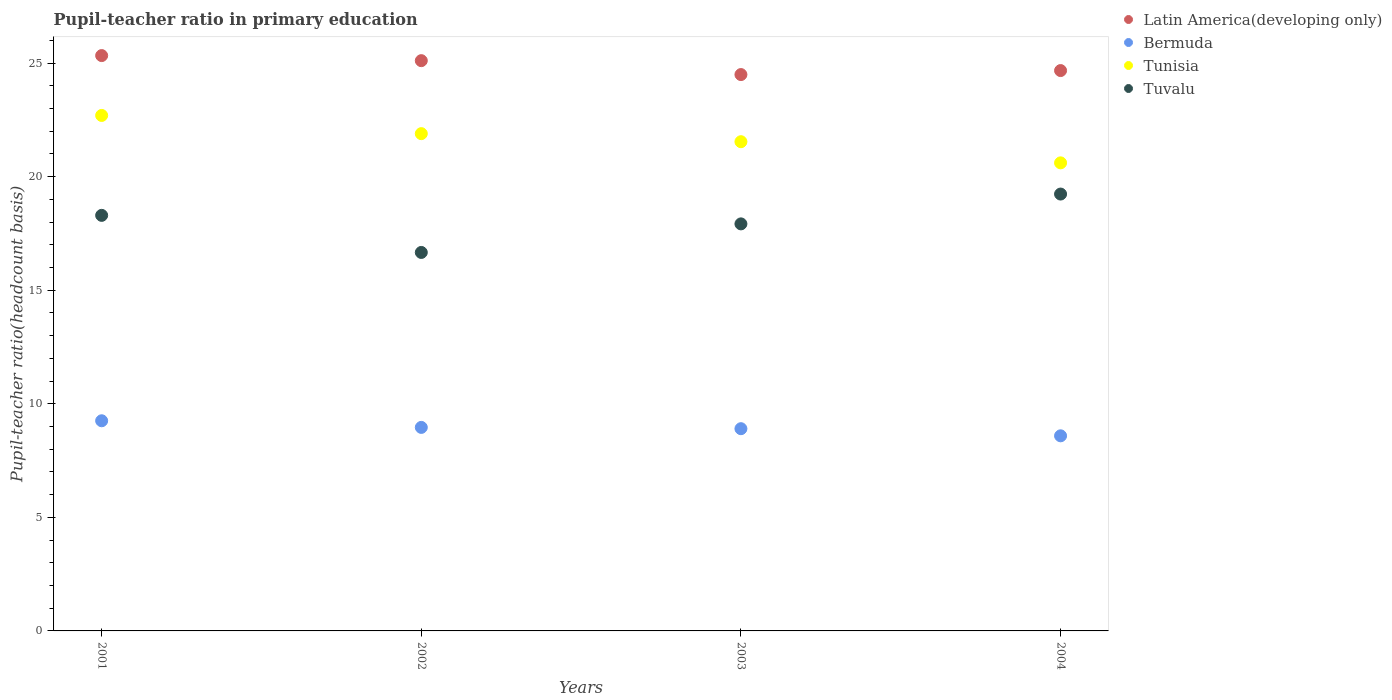How many different coloured dotlines are there?
Give a very brief answer. 4. What is the pupil-teacher ratio in primary education in Bermuda in 2001?
Give a very brief answer. 9.25. Across all years, what is the maximum pupil-teacher ratio in primary education in Tuvalu?
Provide a short and direct response. 19.23. Across all years, what is the minimum pupil-teacher ratio in primary education in Tunisia?
Your answer should be very brief. 20.61. What is the total pupil-teacher ratio in primary education in Tuvalu in the graph?
Your answer should be very brief. 72.11. What is the difference between the pupil-teacher ratio in primary education in Tunisia in 2002 and that in 2004?
Provide a succinct answer. 1.29. What is the difference between the pupil-teacher ratio in primary education in Tunisia in 2002 and the pupil-teacher ratio in primary education in Bermuda in 2001?
Give a very brief answer. 12.64. What is the average pupil-teacher ratio in primary education in Latin America(developing only) per year?
Your answer should be compact. 24.9. In the year 2001, what is the difference between the pupil-teacher ratio in primary education in Bermuda and pupil-teacher ratio in primary education in Tuvalu?
Make the answer very short. -9.04. In how many years, is the pupil-teacher ratio in primary education in Bermuda greater than 15?
Your answer should be very brief. 0. What is the ratio of the pupil-teacher ratio in primary education in Tunisia in 2001 to that in 2003?
Provide a short and direct response. 1.05. Is the pupil-teacher ratio in primary education in Tuvalu in 2002 less than that in 2004?
Provide a succinct answer. Yes. What is the difference between the highest and the second highest pupil-teacher ratio in primary education in Tunisia?
Offer a very short reply. 0.8. What is the difference between the highest and the lowest pupil-teacher ratio in primary education in Tunisia?
Your answer should be very brief. 2.09. Is it the case that in every year, the sum of the pupil-teacher ratio in primary education in Latin America(developing only) and pupil-teacher ratio in primary education in Bermuda  is greater than the sum of pupil-teacher ratio in primary education in Tuvalu and pupil-teacher ratio in primary education in Tunisia?
Give a very brief answer. No. Is the pupil-teacher ratio in primary education in Tunisia strictly greater than the pupil-teacher ratio in primary education in Latin America(developing only) over the years?
Provide a succinct answer. No. What is the difference between two consecutive major ticks on the Y-axis?
Your answer should be compact. 5. Does the graph contain grids?
Your response must be concise. No. Where does the legend appear in the graph?
Provide a short and direct response. Top right. How many legend labels are there?
Offer a terse response. 4. What is the title of the graph?
Provide a succinct answer. Pupil-teacher ratio in primary education. Does "Sudan" appear as one of the legend labels in the graph?
Provide a short and direct response. No. What is the label or title of the X-axis?
Make the answer very short. Years. What is the label or title of the Y-axis?
Offer a terse response. Pupil-teacher ratio(headcount basis). What is the Pupil-teacher ratio(headcount basis) in Latin America(developing only) in 2001?
Give a very brief answer. 25.33. What is the Pupil-teacher ratio(headcount basis) in Bermuda in 2001?
Keep it short and to the point. 9.25. What is the Pupil-teacher ratio(headcount basis) of Tunisia in 2001?
Give a very brief answer. 22.69. What is the Pupil-teacher ratio(headcount basis) of Tuvalu in 2001?
Your answer should be very brief. 18.29. What is the Pupil-teacher ratio(headcount basis) in Latin America(developing only) in 2002?
Give a very brief answer. 25.11. What is the Pupil-teacher ratio(headcount basis) in Bermuda in 2002?
Your response must be concise. 8.96. What is the Pupil-teacher ratio(headcount basis) in Tunisia in 2002?
Provide a succinct answer. 21.89. What is the Pupil-teacher ratio(headcount basis) in Tuvalu in 2002?
Your answer should be compact. 16.66. What is the Pupil-teacher ratio(headcount basis) of Latin America(developing only) in 2003?
Your answer should be very brief. 24.49. What is the Pupil-teacher ratio(headcount basis) of Bermuda in 2003?
Make the answer very short. 8.9. What is the Pupil-teacher ratio(headcount basis) in Tunisia in 2003?
Offer a terse response. 21.54. What is the Pupil-teacher ratio(headcount basis) of Tuvalu in 2003?
Keep it short and to the point. 17.92. What is the Pupil-teacher ratio(headcount basis) in Latin America(developing only) in 2004?
Offer a terse response. 24.67. What is the Pupil-teacher ratio(headcount basis) in Bermuda in 2004?
Keep it short and to the point. 8.59. What is the Pupil-teacher ratio(headcount basis) of Tunisia in 2004?
Your answer should be compact. 20.61. What is the Pupil-teacher ratio(headcount basis) of Tuvalu in 2004?
Your response must be concise. 19.23. Across all years, what is the maximum Pupil-teacher ratio(headcount basis) in Latin America(developing only)?
Provide a succinct answer. 25.33. Across all years, what is the maximum Pupil-teacher ratio(headcount basis) in Bermuda?
Your answer should be very brief. 9.25. Across all years, what is the maximum Pupil-teacher ratio(headcount basis) in Tunisia?
Your answer should be compact. 22.69. Across all years, what is the maximum Pupil-teacher ratio(headcount basis) of Tuvalu?
Your response must be concise. 19.23. Across all years, what is the minimum Pupil-teacher ratio(headcount basis) of Latin America(developing only)?
Provide a succinct answer. 24.49. Across all years, what is the minimum Pupil-teacher ratio(headcount basis) of Bermuda?
Offer a very short reply. 8.59. Across all years, what is the minimum Pupil-teacher ratio(headcount basis) of Tunisia?
Provide a succinct answer. 20.61. Across all years, what is the minimum Pupil-teacher ratio(headcount basis) in Tuvalu?
Provide a succinct answer. 16.66. What is the total Pupil-teacher ratio(headcount basis) of Latin America(developing only) in the graph?
Your answer should be compact. 99.6. What is the total Pupil-teacher ratio(headcount basis) in Bermuda in the graph?
Keep it short and to the point. 35.7. What is the total Pupil-teacher ratio(headcount basis) of Tunisia in the graph?
Your response must be concise. 86.73. What is the total Pupil-teacher ratio(headcount basis) of Tuvalu in the graph?
Your answer should be compact. 72.11. What is the difference between the Pupil-teacher ratio(headcount basis) of Latin America(developing only) in 2001 and that in 2002?
Offer a very short reply. 0.22. What is the difference between the Pupil-teacher ratio(headcount basis) of Bermuda in 2001 and that in 2002?
Offer a very short reply. 0.29. What is the difference between the Pupil-teacher ratio(headcount basis) in Tunisia in 2001 and that in 2002?
Provide a short and direct response. 0.8. What is the difference between the Pupil-teacher ratio(headcount basis) in Tuvalu in 2001 and that in 2002?
Your answer should be very brief. 1.63. What is the difference between the Pupil-teacher ratio(headcount basis) of Latin America(developing only) in 2001 and that in 2003?
Provide a succinct answer. 0.84. What is the difference between the Pupil-teacher ratio(headcount basis) of Bermuda in 2001 and that in 2003?
Your answer should be very brief. 0.35. What is the difference between the Pupil-teacher ratio(headcount basis) of Tunisia in 2001 and that in 2003?
Offer a very short reply. 1.16. What is the difference between the Pupil-teacher ratio(headcount basis) of Tuvalu in 2001 and that in 2003?
Your answer should be compact. 0.37. What is the difference between the Pupil-teacher ratio(headcount basis) of Latin America(developing only) in 2001 and that in 2004?
Give a very brief answer. 0.66. What is the difference between the Pupil-teacher ratio(headcount basis) of Bermuda in 2001 and that in 2004?
Offer a very short reply. 0.66. What is the difference between the Pupil-teacher ratio(headcount basis) in Tunisia in 2001 and that in 2004?
Provide a succinct answer. 2.09. What is the difference between the Pupil-teacher ratio(headcount basis) of Tuvalu in 2001 and that in 2004?
Offer a terse response. -0.94. What is the difference between the Pupil-teacher ratio(headcount basis) in Latin America(developing only) in 2002 and that in 2003?
Make the answer very short. 0.61. What is the difference between the Pupil-teacher ratio(headcount basis) of Bermuda in 2002 and that in 2003?
Make the answer very short. 0.06. What is the difference between the Pupil-teacher ratio(headcount basis) of Tunisia in 2002 and that in 2003?
Offer a terse response. 0.35. What is the difference between the Pupil-teacher ratio(headcount basis) in Tuvalu in 2002 and that in 2003?
Your answer should be very brief. -1.26. What is the difference between the Pupil-teacher ratio(headcount basis) in Latin America(developing only) in 2002 and that in 2004?
Provide a succinct answer. 0.44. What is the difference between the Pupil-teacher ratio(headcount basis) in Bermuda in 2002 and that in 2004?
Ensure brevity in your answer.  0.37. What is the difference between the Pupil-teacher ratio(headcount basis) of Tunisia in 2002 and that in 2004?
Make the answer very short. 1.29. What is the difference between the Pupil-teacher ratio(headcount basis) in Tuvalu in 2002 and that in 2004?
Your answer should be compact. -2.57. What is the difference between the Pupil-teacher ratio(headcount basis) in Latin America(developing only) in 2003 and that in 2004?
Provide a succinct answer. -0.18. What is the difference between the Pupil-teacher ratio(headcount basis) of Bermuda in 2003 and that in 2004?
Give a very brief answer. 0.31. What is the difference between the Pupil-teacher ratio(headcount basis) of Tunisia in 2003 and that in 2004?
Your response must be concise. 0.93. What is the difference between the Pupil-teacher ratio(headcount basis) of Tuvalu in 2003 and that in 2004?
Your answer should be very brief. -1.31. What is the difference between the Pupil-teacher ratio(headcount basis) of Latin America(developing only) in 2001 and the Pupil-teacher ratio(headcount basis) of Bermuda in 2002?
Provide a succinct answer. 16.37. What is the difference between the Pupil-teacher ratio(headcount basis) in Latin America(developing only) in 2001 and the Pupil-teacher ratio(headcount basis) in Tunisia in 2002?
Your response must be concise. 3.44. What is the difference between the Pupil-teacher ratio(headcount basis) of Latin America(developing only) in 2001 and the Pupil-teacher ratio(headcount basis) of Tuvalu in 2002?
Offer a very short reply. 8.67. What is the difference between the Pupil-teacher ratio(headcount basis) of Bermuda in 2001 and the Pupil-teacher ratio(headcount basis) of Tunisia in 2002?
Your response must be concise. -12.64. What is the difference between the Pupil-teacher ratio(headcount basis) in Bermuda in 2001 and the Pupil-teacher ratio(headcount basis) in Tuvalu in 2002?
Offer a very short reply. -7.41. What is the difference between the Pupil-teacher ratio(headcount basis) in Tunisia in 2001 and the Pupil-teacher ratio(headcount basis) in Tuvalu in 2002?
Your answer should be very brief. 6.03. What is the difference between the Pupil-teacher ratio(headcount basis) in Latin America(developing only) in 2001 and the Pupil-teacher ratio(headcount basis) in Bermuda in 2003?
Give a very brief answer. 16.43. What is the difference between the Pupil-teacher ratio(headcount basis) in Latin America(developing only) in 2001 and the Pupil-teacher ratio(headcount basis) in Tunisia in 2003?
Give a very brief answer. 3.79. What is the difference between the Pupil-teacher ratio(headcount basis) in Latin America(developing only) in 2001 and the Pupil-teacher ratio(headcount basis) in Tuvalu in 2003?
Offer a very short reply. 7.41. What is the difference between the Pupil-teacher ratio(headcount basis) of Bermuda in 2001 and the Pupil-teacher ratio(headcount basis) of Tunisia in 2003?
Keep it short and to the point. -12.29. What is the difference between the Pupil-teacher ratio(headcount basis) of Bermuda in 2001 and the Pupil-teacher ratio(headcount basis) of Tuvalu in 2003?
Make the answer very short. -8.67. What is the difference between the Pupil-teacher ratio(headcount basis) in Tunisia in 2001 and the Pupil-teacher ratio(headcount basis) in Tuvalu in 2003?
Provide a succinct answer. 4.77. What is the difference between the Pupil-teacher ratio(headcount basis) in Latin America(developing only) in 2001 and the Pupil-teacher ratio(headcount basis) in Bermuda in 2004?
Ensure brevity in your answer.  16.74. What is the difference between the Pupil-teacher ratio(headcount basis) in Latin America(developing only) in 2001 and the Pupil-teacher ratio(headcount basis) in Tunisia in 2004?
Make the answer very short. 4.72. What is the difference between the Pupil-teacher ratio(headcount basis) in Latin America(developing only) in 2001 and the Pupil-teacher ratio(headcount basis) in Tuvalu in 2004?
Your answer should be compact. 6.1. What is the difference between the Pupil-teacher ratio(headcount basis) of Bermuda in 2001 and the Pupil-teacher ratio(headcount basis) of Tunisia in 2004?
Your answer should be compact. -11.35. What is the difference between the Pupil-teacher ratio(headcount basis) in Bermuda in 2001 and the Pupil-teacher ratio(headcount basis) in Tuvalu in 2004?
Provide a succinct answer. -9.98. What is the difference between the Pupil-teacher ratio(headcount basis) of Tunisia in 2001 and the Pupil-teacher ratio(headcount basis) of Tuvalu in 2004?
Keep it short and to the point. 3.46. What is the difference between the Pupil-teacher ratio(headcount basis) in Latin America(developing only) in 2002 and the Pupil-teacher ratio(headcount basis) in Bermuda in 2003?
Offer a terse response. 16.2. What is the difference between the Pupil-teacher ratio(headcount basis) in Latin America(developing only) in 2002 and the Pupil-teacher ratio(headcount basis) in Tunisia in 2003?
Ensure brevity in your answer.  3.57. What is the difference between the Pupil-teacher ratio(headcount basis) of Latin America(developing only) in 2002 and the Pupil-teacher ratio(headcount basis) of Tuvalu in 2003?
Give a very brief answer. 7.19. What is the difference between the Pupil-teacher ratio(headcount basis) in Bermuda in 2002 and the Pupil-teacher ratio(headcount basis) in Tunisia in 2003?
Keep it short and to the point. -12.58. What is the difference between the Pupil-teacher ratio(headcount basis) of Bermuda in 2002 and the Pupil-teacher ratio(headcount basis) of Tuvalu in 2003?
Make the answer very short. -8.96. What is the difference between the Pupil-teacher ratio(headcount basis) in Tunisia in 2002 and the Pupil-teacher ratio(headcount basis) in Tuvalu in 2003?
Give a very brief answer. 3.97. What is the difference between the Pupil-teacher ratio(headcount basis) in Latin America(developing only) in 2002 and the Pupil-teacher ratio(headcount basis) in Bermuda in 2004?
Offer a terse response. 16.52. What is the difference between the Pupil-teacher ratio(headcount basis) of Latin America(developing only) in 2002 and the Pupil-teacher ratio(headcount basis) of Tunisia in 2004?
Your response must be concise. 4.5. What is the difference between the Pupil-teacher ratio(headcount basis) in Latin America(developing only) in 2002 and the Pupil-teacher ratio(headcount basis) in Tuvalu in 2004?
Your answer should be very brief. 5.87. What is the difference between the Pupil-teacher ratio(headcount basis) in Bermuda in 2002 and the Pupil-teacher ratio(headcount basis) in Tunisia in 2004?
Ensure brevity in your answer.  -11.65. What is the difference between the Pupil-teacher ratio(headcount basis) in Bermuda in 2002 and the Pupil-teacher ratio(headcount basis) in Tuvalu in 2004?
Provide a succinct answer. -10.27. What is the difference between the Pupil-teacher ratio(headcount basis) in Tunisia in 2002 and the Pupil-teacher ratio(headcount basis) in Tuvalu in 2004?
Your response must be concise. 2.66. What is the difference between the Pupil-teacher ratio(headcount basis) in Latin America(developing only) in 2003 and the Pupil-teacher ratio(headcount basis) in Bermuda in 2004?
Provide a short and direct response. 15.9. What is the difference between the Pupil-teacher ratio(headcount basis) of Latin America(developing only) in 2003 and the Pupil-teacher ratio(headcount basis) of Tunisia in 2004?
Your response must be concise. 3.89. What is the difference between the Pupil-teacher ratio(headcount basis) of Latin America(developing only) in 2003 and the Pupil-teacher ratio(headcount basis) of Tuvalu in 2004?
Your answer should be very brief. 5.26. What is the difference between the Pupil-teacher ratio(headcount basis) of Bermuda in 2003 and the Pupil-teacher ratio(headcount basis) of Tunisia in 2004?
Your answer should be very brief. -11.7. What is the difference between the Pupil-teacher ratio(headcount basis) in Bermuda in 2003 and the Pupil-teacher ratio(headcount basis) in Tuvalu in 2004?
Provide a short and direct response. -10.33. What is the difference between the Pupil-teacher ratio(headcount basis) in Tunisia in 2003 and the Pupil-teacher ratio(headcount basis) in Tuvalu in 2004?
Give a very brief answer. 2.3. What is the average Pupil-teacher ratio(headcount basis) of Latin America(developing only) per year?
Provide a short and direct response. 24.9. What is the average Pupil-teacher ratio(headcount basis) in Bermuda per year?
Your answer should be compact. 8.93. What is the average Pupil-teacher ratio(headcount basis) of Tunisia per year?
Offer a terse response. 21.68. What is the average Pupil-teacher ratio(headcount basis) of Tuvalu per year?
Your response must be concise. 18.03. In the year 2001, what is the difference between the Pupil-teacher ratio(headcount basis) of Latin America(developing only) and Pupil-teacher ratio(headcount basis) of Bermuda?
Give a very brief answer. 16.08. In the year 2001, what is the difference between the Pupil-teacher ratio(headcount basis) in Latin America(developing only) and Pupil-teacher ratio(headcount basis) in Tunisia?
Offer a very short reply. 2.64. In the year 2001, what is the difference between the Pupil-teacher ratio(headcount basis) in Latin America(developing only) and Pupil-teacher ratio(headcount basis) in Tuvalu?
Your answer should be compact. 7.03. In the year 2001, what is the difference between the Pupil-teacher ratio(headcount basis) in Bermuda and Pupil-teacher ratio(headcount basis) in Tunisia?
Your answer should be very brief. -13.44. In the year 2001, what is the difference between the Pupil-teacher ratio(headcount basis) of Bermuda and Pupil-teacher ratio(headcount basis) of Tuvalu?
Ensure brevity in your answer.  -9.04. In the year 2001, what is the difference between the Pupil-teacher ratio(headcount basis) in Tunisia and Pupil-teacher ratio(headcount basis) in Tuvalu?
Your response must be concise. 4.4. In the year 2002, what is the difference between the Pupil-teacher ratio(headcount basis) of Latin America(developing only) and Pupil-teacher ratio(headcount basis) of Bermuda?
Offer a very short reply. 16.15. In the year 2002, what is the difference between the Pupil-teacher ratio(headcount basis) in Latin America(developing only) and Pupil-teacher ratio(headcount basis) in Tunisia?
Make the answer very short. 3.21. In the year 2002, what is the difference between the Pupil-teacher ratio(headcount basis) in Latin America(developing only) and Pupil-teacher ratio(headcount basis) in Tuvalu?
Provide a succinct answer. 8.44. In the year 2002, what is the difference between the Pupil-teacher ratio(headcount basis) of Bermuda and Pupil-teacher ratio(headcount basis) of Tunisia?
Provide a short and direct response. -12.93. In the year 2002, what is the difference between the Pupil-teacher ratio(headcount basis) in Bermuda and Pupil-teacher ratio(headcount basis) in Tuvalu?
Keep it short and to the point. -7.7. In the year 2002, what is the difference between the Pupil-teacher ratio(headcount basis) in Tunisia and Pupil-teacher ratio(headcount basis) in Tuvalu?
Keep it short and to the point. 5.23. In the year 2003, what is the difference between the Pupil-teacher ratio(headcount basis) in Latin America(developing only) and Pupil-teacher ratio(headcount basis) in Bermuda?
Offer a terse response. 15.59. In the year 2003, what is the difference between the Pupil-teacher ratio(headcount basis) of Latin America(developing only) and Pupil-teacher ratio(headcount basis) of Tunisia?
Provide a succinct answer. 2.96. In the year 2003, what is the difference between the Pupil-teacher ratio(headcount basis) of Latin America(developing only) and Pupil-teacher ratio(headcount basis) of Tuvalu?
Provide a short and direct response. 6.57. In the year 2003, what is the difference between the Pupil-teacher ratio(headcount basis) in Bermuda and Pupil-teacher ratio(headcount basis) in Tunisia?
Offer a terse response. -12.63. In the year 2003, what is the difference between the Pupil-teacher ratio(headcount basis) of Bermuda and Pupil-teacher ratio(headcount basis) of Tuvalu?
Your answer should be very brief. -9.02. In the year 2003, what is the difference between the Pupil-teacher ratio(headcount basis) in Tunisia and Pupil-teacher ratio(headcount basis) in Tuvalu?
Make the answer very short. 3.62. In the year 2004, what is the difference between the Pupil-teacher ratio(headcount basis) of Latin America(developing only) and Pupil-teacher ratio(headcount basis) of Bermuda?
Make the answer very short. 16.08. In the year 2004, what is the difference between the Pupil-teacher ratio(headcount basis) in Latin America(developing only) and Pupil-teacher ratio(headcount basis) in Tunisia?
Your response must be concise. 4.06. In the year 2004, what is the difference between the Pupil-teacher ratio(headcount basis) of Latin America(developing only) and Pupil-teacher ratio(headcount basis) of Tuvalu?
Offer a terse response. 5.44. In the year 2004, what is the difference between the Pupil-teacher ratio(headcount basis) in Bermuda and Pupil-teacher ratio(headcount basis) in Tunisia?
Make the answer very short. -12.02. In the year 2004, what is the difference between the Pupil-teacher ratio(headcount basis) in Bermuda and Pupil-teacher ratio(headcount basis) in Tuvalu?
Your answer should be compact. -10.64. In the year 2004, what is the difference between the Pupil-teacher ratio(headcount basis) of Tunisia and Pupil-teacher ratio(headcount basis) of Tuvalu?
Keep it short and to the point. 1.37. What is the ratio of the Pupil-teacher ratio(headcount basis) of Latin America(developing only) in 2001 to that in 2002?
Provide a short and direct response. 1.01. What is the ratio of the Pupil-teacher ratio(headcount basis) in Bermuda in 2001 to that in 2002?
Your response must be concise. 1.03. What is the ratio of the Pupil-teacher ratio(headcount basis) of Tunisia in 2001 to that in 2002?
Give a very brief answer. 1.04. What is the ratio of the Pupil-teacher ratio(headcount basis) in Tuvalu in 2001 to that in 2002?
Give a very brief answer. 1.1. What is the ratio of the Pupil-teacher ratio(headcount basis) of Latin America(developing only) in 2001 to that in 2003?
Your answer should be very brief. 1.03. What is the ratio of the Pupil-teacher ratio(headcount basis) of Bermuda in 2001 to that in 2003?
Your answer should be compact. 1.04. What is the ratio of the Pupil-teacher ratio(headcount basis) in Tunisia in 2001 to that in 2003?
Keep it short and to the point. 1.05. What is the ratio of the Pupil-teacher ratio(headcount basis) of Tuvalu in 2001 to that in 2003?
Offer a terse response. 1.02. What is the ratio of the Pupil-teacher ratio(headcount basis) of Latin America(developing only) in 2001 to that in 2004?
Offer a very short reply. 1.03. What is the ratio of the Pupil-teacher ratio(headcount basis) of Bermuda in 2001 to that in 2004?
Offer a very short reply. 1.08. What is the ratio of the Pupil-teacher ratio(headcount basis) of Tunisia in 2001 to that in 2004?
Give a very brief answer. 1.1. What is the ratio of the Pupil-teacher ratio(headcount basis) of Tuvalu in 2001 to that in 2004?
Offer a terse response. 0.95. What is the ratio of the Pupil-teacher ratio(headcount basis) in Bermuda in 2002 to that in 2003?
Offer a very short reply. 1.01. What is the ratio of the Pupil-teacher ratio(headcount basis) of Tunisia in 2002 to that in 2003?
Keep it short and to the point. 1.02. What is the ratio of the Pupil-teacher ratio(headcount basis) in Tuvalu in 2002 to that in 2003?
Provide a short and direct response. 0.93. What is the ratio of the Pupil-teacher ratio(headcount basis) in Latin America(developing only) in 2002 to that in 2004?
Offer a very short reply. 1.02. What is the ratio of the Pupil-teacher ratio(headcount basis) of Bermuda in 2002 to that in 2004?
Ensure brevity in your answer.  1.04. What is the ratio of the Pupil-teacher ratio(headcount basis) in Tunisia in 2002 to that in 2004?
Make the answer very short. 1.06. What is the ratio of the Pupil-teacher ratio(headcount basis) in Tuvalu in 2002 to that in 2004?
Provide a succinct answer. 0.87. What is the ratio of the Pupil-teacher ratio(headcount basis) of Latin America(developing only) in 2003 to that in 2004?
Your answer should be compact. 0.99. What is the ratio of the Pupil-teacher ratio(headcount basis) in Bermuda in 2003 to that in 2004?
Your answer should be very brief. 1.04. What is the ratio of the Pupil-teacher ratio(headcount basis) of Tunisia in 2003 to that in 2004?
Your answer should be very brief. 1.05. What is the ratio of the Pupil-teacher ratio(headcount basis) in Tuvalu in 2003 to that in 2004?
Your response must be concise. 0.93. What is the difference between the highest and the second highest Pupil-teacher ratio(headcount basis) of Latin America(developing only)?
Your response must be concise. 0.22. What is the difference between the highest and the second highest Pupil-teacher ratio(headcount basis) in Bermuda?
Provide a succinct answer. 0.29. What is the difference between the highest and the second highest Pupil-teacher ratio(headcount basis) of Tunisia?
Provide a short and direct response. 0.8. What is the difference between the highest and the second highest Pupil-teacher ratio(headcount basis) of Tuvalu?
Offer a terse response. 0.94. What is the difference between the highest and the lowest Pupil-teacher ratio(headcount basis) of Latin America(developing only)?
Provide a short and direct response. 0.84. What is the difference between the highest and the lowest Pupil-teacher ratio(headcount basis) in Bermuda?
Your response must be concise. 0.66. What is the difference between the highest and the lowest Pupil-teacher ratio(headcount basis) of Tunisia?
Provide a succinct answer. 2.09. What is the difference between the highest and the lowest Pupil-teacher ratio(headcount basis) in Tuvalu?
Make the answer very short. 2.57. 